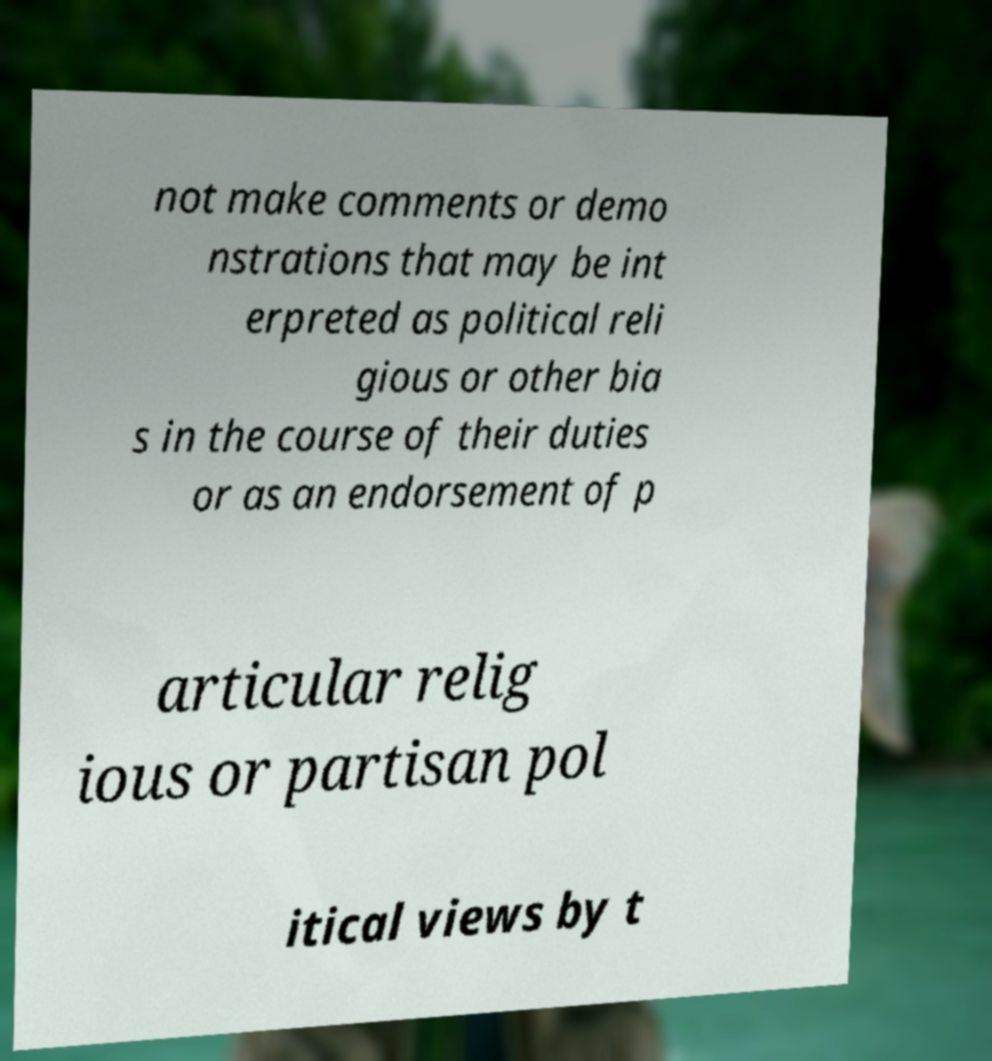Can you read and provide the text displayed in the image?This photo seems to have some interesting text. Can you extract and type it out for me? not make comments or demo nstrations that may be int erpreted as political reli gious or other bia s in the course of their duties or as an endorsement of p articular relig ious or partisan pol itical views by t 